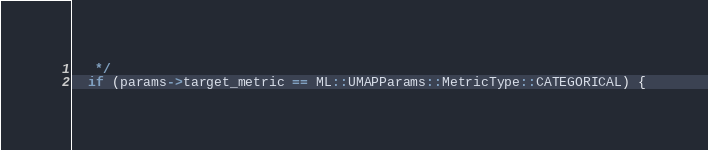<code> <loc_0><loc_0><loc_500><loc_500><_Cuda_>   */
  if (params->target_metric == ML::UMAPParams::MetricType::CATEGORICAL) {</code> 